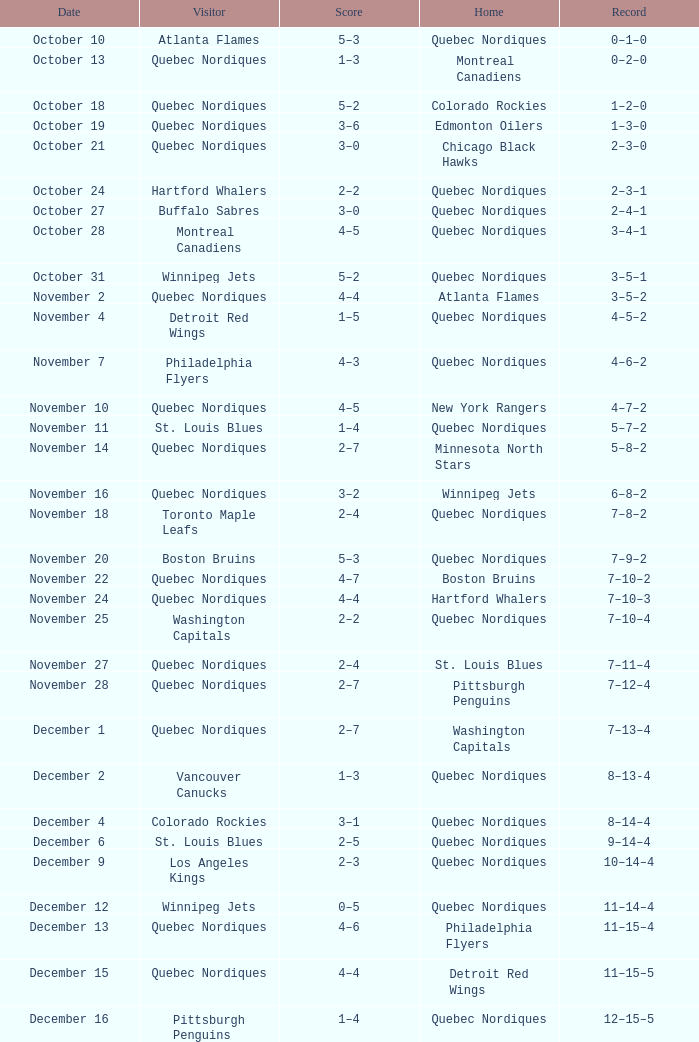Which record holds a score of 2-4, and a home of quebec nordiques? 7–8–2. 